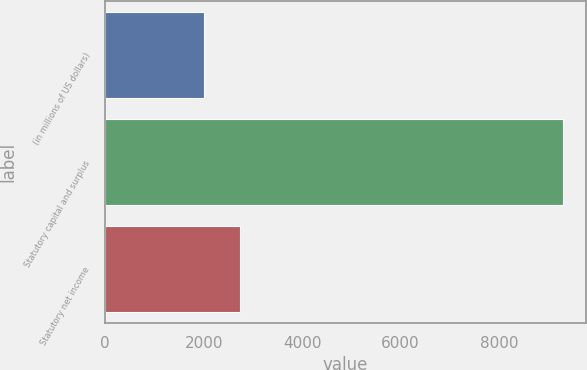Convert chart. <chart><loc_0><loc_0><loc_500><loc_500><bar_chart><fcel>(in millions of US dollars)<fcel>Statutory capital and surplus<fcel>Statutory net income<nl><fcel>2009<fcel>9299<fcel>2738<nl></chart> 